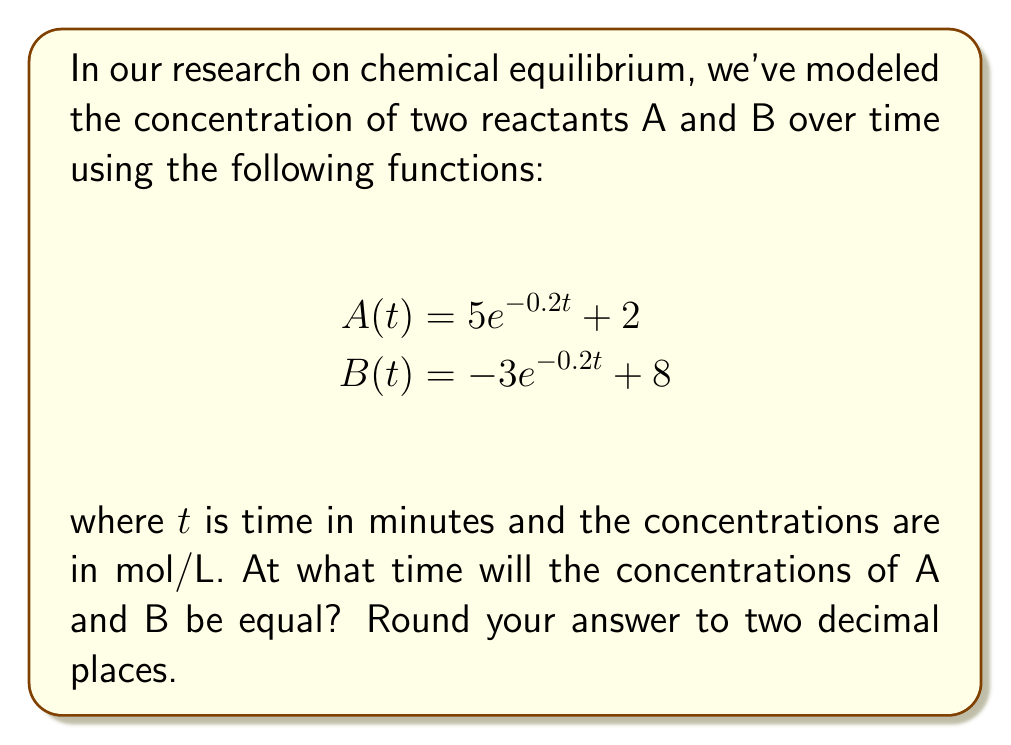Can you answer this question? To find when the concentrations of A and B are equal, we need to find the intersection point of the two functions. This means solving the equation:

$A(t) = B(t)$

Substituting the given functions:

$5e^{-0.2t} + 2 = -3e^{-0.2t} + 8$

Now, let's solve this equation step by step:

1) First, subtract 2 from both sides:
   $5e^{-0.2t} = -3e^{-0.2t} + 6$

2) Add $3e^{-0.2t}$ to both sides:
   $8e^{-0.2t} = 6$

3) Divide both sides by 8:
   $e^{-0.2t} = \frac{3}{4}$

4) Take the natural logarithm of both sides:
   $\ln(e^{-0.2t}) = \ln(\frac{3}{4})$

5) Simplify the left side using the properties of logarithms:
   $-0.2t = \ln(\frac{3}{4})$

6) Divide both sides by -0.2:
   $t = -\frac{\ln(\frac{3}{4})}{0.2}$

7) Calculate the result:
   $t \approx 1.4384$ minutes

8) Round to two decimal places:
   $t \approx 1.44$ minutes

Therefore, the concentrations of A and B will be equal after approximately 1.44 minutes.
Answer: 1.44 minutes 